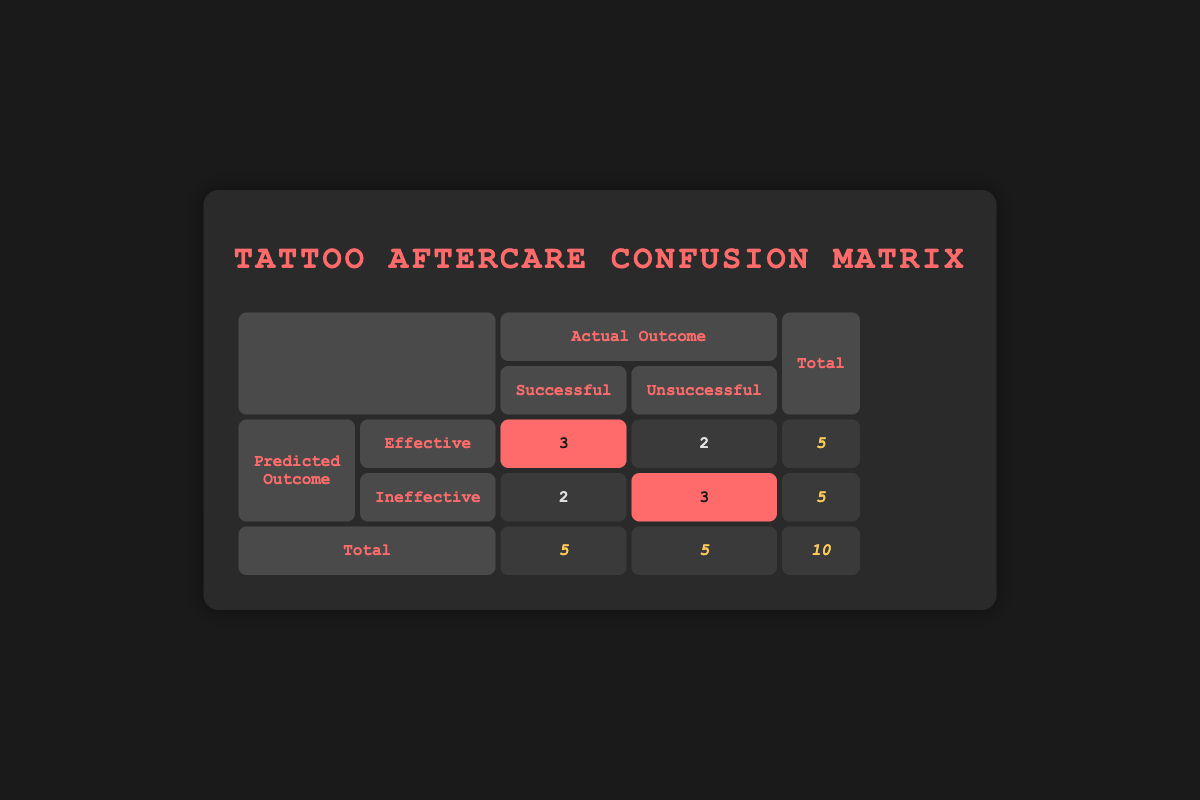What is the total number of participants in the study? The total number of participants is found in the last row of the table under the "Total" column, which shows a count of 10.
Answer: 10 How many participants healed successfully with effective aftercare instruction? The count of participants who healed successfully with effective aftercare instruction is found in the table under the "Effective" row and "Successful" column, which shows a value of 3.
Answer: 3 What percentage of participants with ineffective aftercare healed successfully? To find the percentage, divide the number of participants who healed successfully with ineffective aftercare (2) by the total number of participants with ineffective aftercare (5) and then multiply by 100. Thus, (2/5)*100 = 40%.
Answer: 40% Is it true that more participants healed successfully with effective aftercare than ineffective aftercare? We compare the two groups: 3 participants healed successfully with effective aftercare, while 2 healed successfully with ineffective aftercare. Since 3 is greater than 2, the statement is true.
Answer: Yes What is the difference in the number of unsuccessful healing outcomes between effective and ineffective aftercare instructions? The number of unsuccessful outcomes for effective aftercare is 2, and for ineffective aftercare, it's 3. To find the difference, subtract the effective count from the ineffective count: 3 - 2 = 1.
Answer: 1 